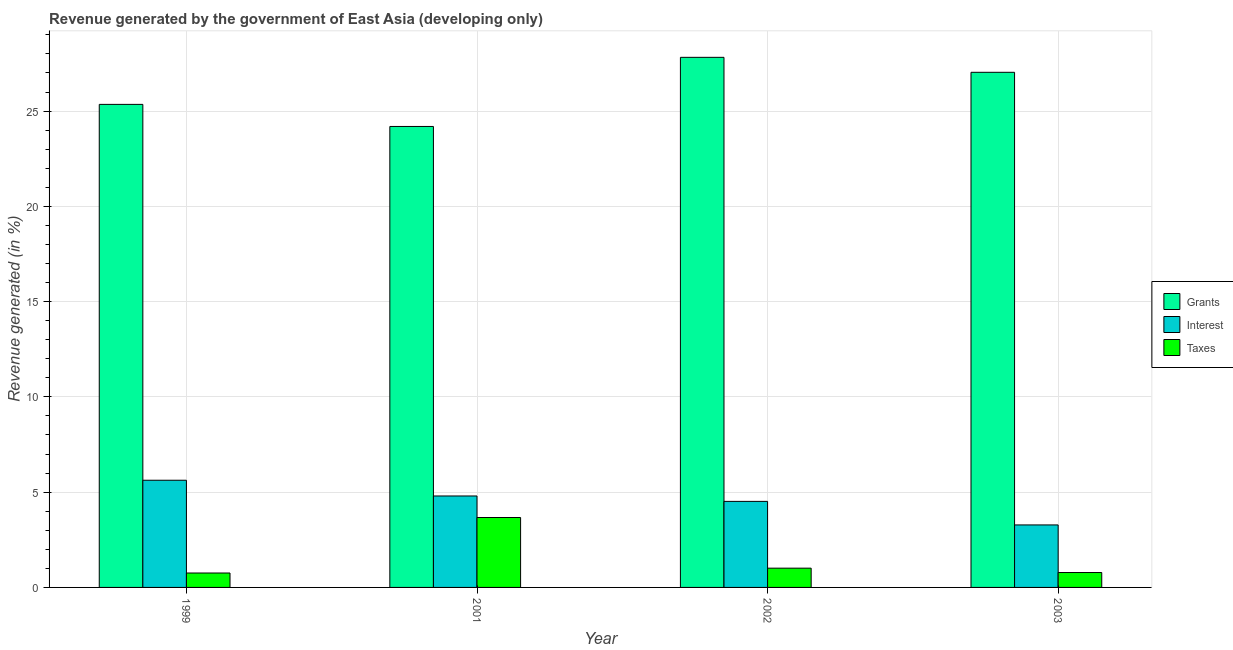How many different coloured bars are there?
Give a very brief answer. 3. Are the number of bars on each tick of the X-axis equal?
Your response must be concise. Yes. How many bars are there on the 3rd tick from the right?
Ensure brevity in your answer.  3. What is the label of the 2nd group of bars from the left?
Your answer should be very brief. 2001. In how many cases, is the number of bars for a given year not equal to the number of legend labels?
Provide a succinct answer. 0. What is the percentage of revenue generated by grants in 2001?
Offer a very short reply. 24.19. Across all years, what is the maximum percentage of revenue generated by grants?
Offer a terse response. 27.82. Across all years, what is the minimum percentage of revenue generated by grants?
Keep it short and to the point. 24.19. In which year was the percentage of revenue generated by interest maximum?
Your answer should be compact. 1999. In which year was the percentage of revenue generated by grants minimum?
Offer a very short reply. 2001. What is the total percentage of revenue generated by interest in the graph?
Keep it short and to the point. 18.22. What is the difference between the percentage of revenue generated by grants in 1999 and that in 2002?
Ensure brevity in your answer.  -2.47. What is the difference between the percentage of revenue generated by interest in 1999 and the percentage of revenue generated by taxes in 2003?
Offer a terse response. 2.35. What is the average percentage of revenue generated by interest per year?
Offer a very short reply. 4.55. In the year 2002, what is the difference between the percentage of revenue generated by grants and percentage of revenue generated by taxes?
Provide a succinct answer. 0. In how many years, is the percentage of revenue generated by taxes greater than 1 %?
Your answer should be compact. 2. What is the ratio of the percentage of revenue generated by grants in 2001 to that in 2002?
Your answer should be very brief. 0.87. Is the percentage of revenue generated by grants in 2001 less than that in 2002?
Keep it short and to the point. Yes. What is the difference between the highest and the second highest percentage of revenue generated by taxes?
Provide a short and direct response. 2.66. What is the difference between the highest and the lowest percentage of revenue generated by interest?
Make the answer very short. 2.35. What does the 2nd bar from the left in 2001 represents?
Make the answer very short. Interest. What does the 3rd bar from the right in 1999 represents?
Make the answer very short. Grants. How many bars are there?
Provide a short and direct response. 12. Are all the bars in the graph horizontal?
Your answer should be compact. No. What is the difference between two consecutive major ticks on the Y-axis?
Make the answer very short. 5. Does the graph contain grids?
Provide a short and direct response. Yes. Where does the legend appear in the graph?
Keep it short and to the point. Center right. How are the legend labels stacked?
Give a very brief answer. Vertical. What is the title of the graph?
Your answer should be very brief. Revenue generated by the government of East Asia (developing only). What is the label or title of the X-axis?
Your answer should be compact. Year. What is the label or title of the Y-axis?
Give a very brief answer. Revenue generated (in %). What is the Revenue generated (in %) in Grants in 1999?
Provide a short and direct response. 25.35. What is the Revenue generated (in %) of Interest in 1999?
Offer a very short reply. 5.63. What is the Revenue generated (in %) of Taxes in 1999?
Your answer should be very brief. 0.76. What is the Revenue generated (in %) in Grants in 2001?
Your answer should be very brief. 24.19. What is the Revenue generated (in %) in Interest in 2001?
Keep it short and to the point. 4.8. What is the Revenue generated (in %) in Taxes in 2001?
Ensure brevity in your answer.  3.67. What is the Revenue generated (in %) in Grants in 2002?
Your answer should be very brief. 27.82. What is the Revenue generated (in %) in Interest in 2002?
Provide a short and direct response. 4.52. What is the Revenue generated (in %) in Taxes in 2002?
Provide a succinct answer. 1.01. What is the Revenue generated (in %) of Grants in 2003?
Your answer should be compact. 27.03. What is the Revenue generated (in %) in Interest in 2003?
Provide a short and direct response. 3.28. What is the Revenue generated (in %) in Taxes in 2003?
Your response must be concise. 0.78. Across all years, what is the maximum Revenue generated (in %) in Grants?
Offer a terse response. 27.82. Across all years, what is the maximum Revenue generated (in %) of Interest?
Offer a very short reply. 5.63. Across all years, what is the maximum Revenue generated (in %) of Taxes?
Keep it short and to the point. 3.67. Across all years, what is the minimum Revenue generated (in %) in Grants?
Your answer should be compact. 24.19. Across all years, what is the minimum Revenue generated (in %) of Interest?
Offer a terse response. 3.28. Across all years, what is the minimum Revenue generated (in %) of Taxes?
Offer a terse response. 0.76. What is the total Revenue generated (in %) of Grants in the graph?
Your answer should be very brief. 104.4. What is the total Revenue generated (in %) of Interest in the graph?
Make the answer very short. 18.22. What is the total Revenue generated (in %) of Taxes in the graph?
Give a very brief answer. 6.22. What is the difference between the Revenue generated (in %) in Grants in 1999 and that in 2001?
Keep it short and to the point. 1.16. What is the difference between the Revenue generated (in %) in Interest in 1999 and that in 2001?
Make the answer very short. 0.83. What is the difference between the Revenue generated (in %) in Taxes in 1999 and that in 2001?
Your answer should be very brief. -2.91. What is the difference between the Revenue generated (in %) of Grants in 1999 and that in 2002?
Offer a terse response. -2.47. What is the difference between the Revenue generated (in %) of Interest in 1999 and that in 2002?
Make the answer very short. 1.11. What is the difference between the Revenue generated (in %) in Taxes in 1999 and that in 2002?
Offer a very short reply. -0.25. What is the difference between the Revenue generated (in %) of Grants in 1999 and that in 2003?
Give a very brief answer. -1.68. What is the difference between the Revenue generated (in %) in Interest in 1999 and that in 2003?
Your response must be concise. 2.35. What is the difference between the Revenue generated (in %) of Taxes in 1999 and that in 2003?
Your answer should be compact. -0.03. What is the difference between the Revenue generated (in %) in Grants in 2001 and that in 2002?
Offer a terse response. -3.63. What is the difference between the Revenue generated (in %) in Interest in 2001 and that in 2002?
Offer a terse response. 0.28. What is the difference between the Revenue generated (in %) of Taxes in 2001 and that in 2002?
Your answer should be compact. 2.66. What is the difference between the Revenue generated (in %) in Grants in 2001 and that in 2003?
Keep it short and to the point. -2.84. What is the difference between the Revenue generated (in %) in Interest in 2001 and that in 2003?
Make the answer very short. 1.52. What is the difference between the Revenue generated (in %) of Taxes in 2001 and that in 2003?
Your answer should be compact. 2.89. What is the difference between the Revenue generated (in %) in Grants in 2002 and that in 2003?
Ensure brevity in your answer.  0.79. What is the difference between the Revenue generated (in %) of Interest in 2002 and that in 2003?
Your response must be concise. 1.24. What is the difference between the Revenue generated (in %) in Taxes in 2002 and that in 2003?
Your response must be concise. 0.23. What is the difference between the Revenue generated (in %) in Grants in 1999 and the Revenue generated (in %) in Interest in 2001?
Ensure brevity in your answer.  20.55. What is the difference between the Revenue generated (in %) of Grants in 1999 and the Revenue generated (in %) of Taxes in 2001?
Provide a succinct answer. 21.68. What is the difference between the Revenue generated (in %) in Interest in 1999 and the Revenue generated (in %) in Taxes in 2001?
Keep it short and to the point. 1.96. What is the difference between the Revenue generated (in %) of Grants in 1999 and the Revenue generated (in %) of Interest in 2002?
Your answer should be very brief. 20.84. What is the difference between the Revenue generated (in %) in Grants in 1999 and the Revenue generated (in %) in Taxes in 2002?
Ensure brevity in your answer.  24.34. What is the difference between the Revenue generated (in %) in Interest in 1999 and the Revenue generated (in %) in Taxes in 2002?
Your answer should be very brief. 4.61. What is the difference between the Revenue generated (in %) in Grants in 1999 and the Revenue generated (in %) in Interest in 2003?
Provide a succinct answer. 22.07. What is the difference between the Revenue generated (in %) of Grants in 1999 and the Revenue generated (in %) of Taxes in 2003?
Your answer should be compact. 24.57. What is the difference between the Revenue generated (in %) in Interest in 1999 and the Revenue generated (in %) in Taxes in 2003?
Give a very brief answer. 4.84. What is the difference between the Revenue generated (in %) of Grants in 2001 and the Revenue generated (in %) of Interest in 2002?
Offer a very short reply. 19.68. What is the difference between the Revenue generated (in %) in Grants in 2001 and the Revenue generated (in %) in Taxes in 2002?
Offer a terse response. 23.18. What is the difference between the Revenue generated (in %) in Interest in 2001 and the Revenue generated (in %) in Taxes in 2002?
Your answer should be very brief. 3.79. What is the difference between the Revenue generated (in %) in Grants in 2001 and the Revenue generated (in %) in Interest in 2003?
Provide a succinct answer. 20.91. What is the difference between the Revenue generated (in %) in Grants in 2001 and the Revenue generated (in %) in Taxes in 2003?
Provide a short and direct response. 23.41. What is the difference between the Revenue generated (in %) in Interest in 2001 and the Revenue generated (in %) in Taxes in 2003?
Your answer should be very brief. 4.02. What is the difference between the Revenue generated (in %) in Grants in 2002 and the Revenue generated (in %) in Interest in 2003?
Your answer should be very brief. 24.54. What is the difference between the Revenue generated (in %) of Grants in 2002 and the Revenue generated (in %) of Taxes in 2003?
Your answer should be compact. 27.04. What is the difference between the Revenue generated (in %) in Interest in 2002 and the Revenue generated (in %) in Taxes in 2003?
Your answer should be compact. 3.73. What is the average Revenue generated (in %) of Grants per year?
Make the answer very short. 26.1. What is the average Revenue generated (in %) of Interest per year?
Keep it short and to the point. 4.55. What is the average Revenue generated (in %) in Taxes per year?
Offer a terse response. 1.55. In the year 1999, what is the difference between the Revenue generated (in %) in Grants and Revenue generated (in %) in Interest?
Offer a very short reply. 19.73. In the year 1999, what is the difference between the Revenue generated (in %) in Grants and Revenue generated (in %) in Taxes?
Offer a terse response. 24.59. In the year 1999, what is the difference between the Revenue generated (in %) of Interest and Revenue generated (in %) of Taxes?
Provide a short and direct response. 4.87. In the year 2001, what is the difference between the Revenue generated (in %) in Grants and Revenue generated (in %) in Interest?
Your answer should be compact. 19.39. In the year 2001, what is the difference between the Revenue generated (in %) in Grants and Revenue generated (in %) in Taxes?
Your answer should be very brief. 20.52. In the year 2001, what is the difference between the Revenue generated (in %) of Interest and Revenue generated (in %) of Taxes?
Your response must be concise. 1.13. In the year 2002, what is the difference between the Revenue generated (in %) of Grants and Revenue generated (in %) of Interest?
Your response must be concise. 23.31. In the year 2002, what is the difference between the Revenue generated (in %) of Grants and Revenue generated (in %) of Taxes?
Give a very brief answer. 26.81. In the year 2002, what is the difference between the Revenue generated (in %) of Interest and Revenue generated (in %) of Taxes?
Your response must be concise. 3.5. In the year 2003, what is the difference between the Revenue generated (in %) of Grants and Revenue generated (in %) of Interest?
Your answer should be compact. 23.76. In the year 2003, what is the difference between the Revenue generated (in %) in Grants and Revenue generated (in %) in Taxes?
Your answer should be compact. 26.25. In the year 2003, what is the difference between the Revenue generated (in %) of Interest and Revenue generated (in %) of Taxes?
Provide a short and direct response. 2.5. What is the ratio of the Revenue generated (in %) in Grants in 1999 to that in 2001?
Your answer should be compact. 1.05. What is the ratio of the Revenue generated (in %) of Interest in 1999 to that in 2001?
Offer a very short reply. 1.17. What is the ratio of the Revenue generated (in %) of Taxes in 1999 to that in 2001?
Your answer should be compact. 0.21. What is the ratio of the Revenue generated (in %) of Grants in 1999 to that in 2002?
Provide a short and direct response. 0.91. What is the ratio of the Revenue generated (in %) in Interest in 1999 to that in 2002?
Offer a terse response. 1.25. What is the ratio of the Revenue generated (in %) of Taxes in 1999 to that in 2002?
Your answer should be compact. 0.75. What is the ratio of the Revenue generated (in %) of Grants in 1999 to that in 2003?
Offer a very short reply. 0.94. What is the ratio of the Revenue generated (in %) of Interest in 1999 to that in 2003?
Offer a very short reply. 1.72. What is the ratio of the Revenue generated (in %) in Taxes in 1999 to that in 2003?
Ensure brevity in your answer.  0.97. What is the ratio of the Revenue generated (in %) of Grants in 2001 to that in 2002?
Keep it short and to the point. 0.87. What is the ratio of the Revenue generated (in %) of Interest in 2001 to that in 2002?
Give a very brief answer. 1.06. What is the ratio of the Revenue generated (in %) of Taxes in 2001 to that in 2002?
Give a very brief answer. 3.63. What is the ratio of the Revenue generated (in %) in Grants in 2001 to that in 2003?
Provide a succinct answer. 0.89. What is the ratio of the Revenue generated (in %) of Interest in 2001 to that in 2003?
Your answer should be very brief. 1.46. What is the ratio of the Revenue generated (in %) in Taxes in 2001 to that in 2003?
Your answer should be compact. 4.69. What is the ratio of the Revenue generated (in %) in Grants in 2002 to that in 2003?
Offer a very short reply. 1.03. What is the ratio of the Revenue generated (in %) of Interest in 2002 to that in 2003?
Offer a terse response. 1.38. What is the ratio of the Revenue generated (in %) of Taxes in 2002 to that in 2003?
Offer a terse response. 1.29. What is the difference between the highest and the second highest Revenue generated (in %) in Grants?
Your answer should be compact. 0.79. What is the difference between the highest and the second highest Revenue generated (in %) of Interest?
Ensure brevity in your answer.  0.83. What is the difference between the highest and the second highest Revenue generated (in %) in Taxes?
Ensure brevity in your answer.  2.66. What is the difference between the highest and the lowest Revenue generated (in %) in Grants?
Your answer should be very brief. 3.63. What is the difference between the highest and the lowest Revenue generated (in %) of Interest?
Provide a short and direct response. 2.35. What is the difference between the highest and the lowest Revenue generated (in %) of Taxes?
Keep it short and to the point. 2.91. 